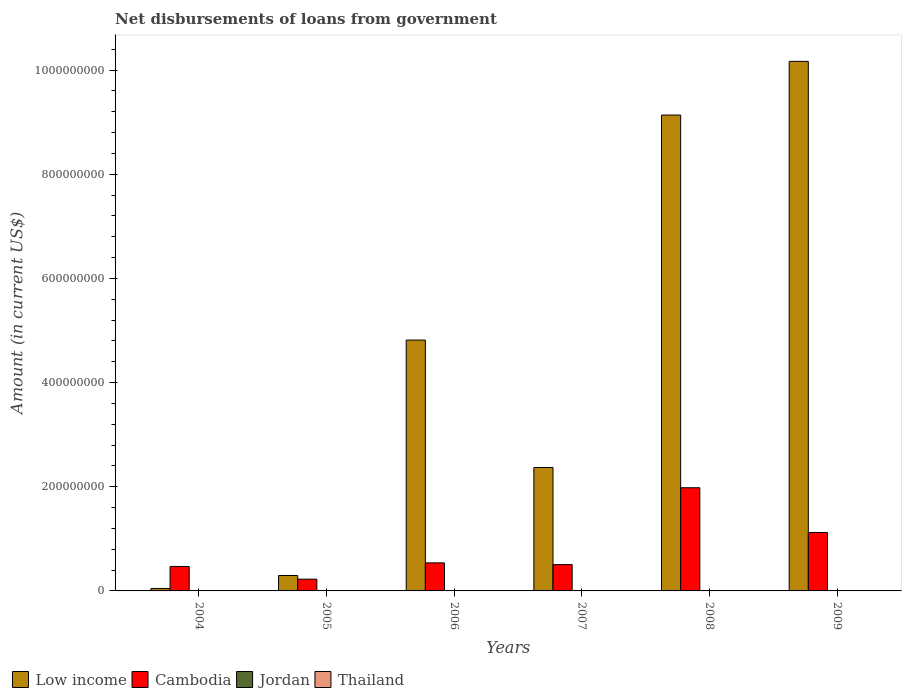What is the amount of loan disbursed from government in Low income in 2005?
Provide a short and direct response. 2.97e+07. In which year was the amount of loan disbursed from government in Cambodia maximum?
Make the answer very short. 2008. What is the total amount of loan disbursed from government in Cambodia in the graph?
Make the answer very short. 4.84e+08. What is the difference between the amount of loan disbursed from government in Low income in 2005 and that in 2006?
Provide a short and direct response. -4.52e+08. What is the difference between the amount of loan disbursed from government in Low income in 2009 and the amount of loan disbursed from government in Thailand in 2004?
Give a very brief answer. 1.02e+09. What is the average amount of loan disbursed from government in Jordan per year?
Keep it short and to the point. 0. In the year 2006, what is the difference between the amount of loan disbursed from government in Low income and amount of loan disbursed from government in Cambodia?
Your answer should be compact. 4.28e+08. In how many years, is the amount of loan disbursed from government in Thailand greater than 200000000 US$?
Keep it short and to the point. 0. What is the ratio of the amount of loan disbursed from government in Low income in 2004 to that in 2006?
Provide a short and direct response. 0.01. Is the amount of loan disbursed from government in Low income in 2005 less than that in 2006?
Your response must be concise. Yes. What is the difference between the highest and the second highest amount of loan disbursed from government in Cambodia?
Provide a short and direct response. 8.59e+07. What is the difference between the highest and the lowest amount of loan disbursed from government in Low income?
Provide a short and direct response. 1.01e+09. Is it the case that in every year, the sum of the amount of loan disbursed from government in Low income and amount of loan disbursed from government in Thailand is greater than the sum of amount of loan disbursed from government in Jordan and amount of loan disbursed from government in Cambodia?
Offer a very short reply. No. Is it the case that in every year, the sum of the amount of loan disbursed from government in Thailand and amount of loan disbursed from government in Low income is greater than the amount of loan disbursed from government in Cambodia?
Make the answer very short. No. Are all the bars in the graph horizontal?
Keep it short and to the point. No. How many years are there in the graph?
Your answer should be very brief. 6. Are the values on the major ticks of Y-axis written in scientific E-notation?
Your answer should be very brief. No. Does the graph contain any zero values?
Ensure brevity in your answer.  Yes. Does the graph contain grids?
Keep it short and to the point. No. How are the legend labels stacked?
Provide a succinct answer. Horizontal. What is the title of the graph?
Give a very brief answer. Net disbursements of loans from government. What is the label or title of the Y-axis?
Offer a terse response. Amount (in current US$). What is the Amount (in current US$) of Low income in 2004?
Provide a succinct answer. 4.73e+06. What is the Amount (in current US$) in Cambodia in 2004?
Your response must be concise. 4.70e+07. What is the Amount (in current US$) of Jordan in 2004?
Provide a short and direct response. 0. What is the Amount (in current US$) of Thailand in 2004?
Ensure brevity in your answer.  0. What is the Amount (in current US$) in Low income in 2005?
Provide a succinct answer. 2.97e+07. What is the Amount (in current US$) in Cambodia in 2005?
Your answer should be very brief. 2.26e+07. What is the Amount (in current US$) in Jordan in 2005?
Provide a short and direct response. 0. What is the Amount (in current US$) of Low income in 2006?
Ensure brevity in your answer.  4.82e+08. What is the Amount (in current US$) in Cambodia in 2006?
Provide a succinct answer. 5.39e+07. What is the Amount (in current US$) in Jordan in 2006?
Give a very brief answer. 0. What is the Amount (in current US$) of Thailand in 2006?
Give a very brief answer. 0. What is the Amount (in current US$) in Low income in 2007?
Your response must be concise. 2.37e+08. What is the Amount (in current US$) of Cambodia in 2007?
Offer a terse response. 5.05e+07. What is the Amount (in current US$) of Jordan in 2007?
Offer a terse response. 0. What is the Amount (in current US$) of Low income in 2008?
Make the answer very short. 9.14e+08. What is the Amount (in current US$) of Cambodia in 2008?
Keep it short and to the point. 1.98e+08. What is the Amount (in current US$) in Low income in 2009?
Give a very brief answer. 1.02e+09. What is the Amount (in current US$) in Cambodia in 2009?
Give a very brief answer. 1.12e+08. What is the Amount (in current US$) in Jordan in 2009?
Offer a very short reply. 0. Across all years, what is the maximum Amount (in current US$) in Low income?
Ensure brevity in your answer.  1.02e+09. Across all years, what is the maximum Amount (in current US$) in Cambodia?
Your answer should be compact. 1.98e+08. Across all years, what is the minimum Amount (in current US$) of Low income?
Ensure brevity in your answer.  4.73e+06. Across all years, what is the minimum Amount (in current US$) of Cambodia?
Keep it short and to the point. 2.26e+07. What is the total Amount (in current US$) in Low income in the graph?
Provide a succinct answer. 2.68e+09. What is the total Amount (in current US$) of Cambodia in the graph?
Your answer should be compact. 4.84e+08. What is the total Amount (in current US$) in Jordan in the graph?
Offer a terse response. 0. What is the difference between the Amount (in current US$) in Low income in 2004 and that in 2005?
Ensure brevity in your answer.  -2.49e+07. What is the difference between the Amount (in current US$) in Cambodia in 2004 and that in 2005?
Offer a very short reply. 2.44e+07. What is the difference between the Amount (in current US$) of Low income in 2004 and that in 2006?
Provide a succinct answer. -4.77e+08. What is the difference between the Amount (in current US$) of Cambodia in 2004 and that in 2006?
Provide a succinct answer. -6.88e+06. What is the difference between the Amount (in current US$) of Low income in 2004 and that in 2007?
Make the answer very short. -2.32e+08. What is the difference between the Amount (in current US$) of Cambodia in 2004 and that in 2007?
Your answer should be compact. -3.54e+06. What is the difference between the Amount (in current US$) in Low income in 2004 and that in 2008?
Your answer should be compact. -9.09e+08. What is the difference between the Amount (in current US$) of Cambodia in 2004 and that in 2008?
Make the answer very short. -1.51e+08. What is the difference between the Amount (in current US$) of Low income in 2004 and that in 2009?
Give a very brief answer. -1.01e+09. What is the difference between the Amount (in current US$) of Cambodia in 2004 and that in 2009?
Your answer should be very brief. -6.52e+07. What is the difference between the Amount (in current US$) in Low income in 2005 and that in 2006?
Provide a succinct answer. -4.52e+08. What is the difference between the Amount (in current US$) in Cambodia in 2005 and that in 2006?
Ensure brevity in your answer.  -3.13e+07. What is the difference between the Amount (in current US$) in Low income in 2005 and that in 2007?
Provide a succinct answer. -2.07e+08. What is the difference between the Amount (in current US$) in Cambodia in 2005 and that in 2007?
Offer a very short reply. -2.79e+07. What is the difference between the Amount (in current US$) of Low income in 2005 and that in 2008?
Provide a short and direct response. -8.84e+08. What is the difference between the Amount (in current US$) in Cambodia in 2005 and that in 2008?
Give a very brief answer. -1.76e+08. What is the difference between the Amount (in current US$) of Low income in 2005 and that in 2009?
Keep it short and to the point. -9.87e+08. What is the difference between the Amount (in current US$) of Cambodia in 2005 and that in 2009?
Give a very brief answer. -8.96e+07. What is the difference between the Amount (in current US$) of Low income in 2006 and that in 2007?
Make the answer very short. 2.45e+08. What is the difference between the Amount (in current US$) of Cambodia in 2006 and that in 2007?
Your answer should be very brief. 3.34e+06. What is the difference between the Amount (in current US$) of Low income in 2006 and that in 2008?
Offer a terse response. -4.32e+08. What is the difference between the Amount (in current US$) in Cambodia in 2006 and that in 2008?
Your answer should be very brief. -1.44e+08. What is the difference between the Amount (in current US$) of Low income in 2006 and that in 2009?
Provide a succinct answer. -5.35e+08. What is the difference between the Amount (in current US$) of Cambodia in 2006 and that in 2009?
Make the answer very short. -5.84e+07. What is the difference between the Amount (in current US$) in Low income in 2007 and that in 2008?
Keep it short and to the point. -6.77e+08. What is the difference between the Amount (in current US$) in Cambodia in 2007 and that in 2008?
Offer a very short reply. -1.48e+08. What is the difference between the Amount (in current US$) of Low income in 2007 and that in 2009?
Offer a terse response. -7.80e+08. What is the difference between the Amount (in current US$) of Cambodia in 2007 and that in 2009?
Ensure brevity in your answer.  -6.17e+07. What is the difference between the Amount (in current US$) of Low income in 2008 and that in 2009?
Your response must be concise. -1.03e+08. What is the difference between the Amount (in current US$) of Cambodia in 2008 and that in 2009?
Your answer should be compact. 8.59e+07. What is the difference between the Amount (in current US$) of Low income in 2004 and the Amount (in current US$) of Cambodia in 2005?
Make the answer very short. -1.78e+07. What is the difference between the Amount (in current US$) in Low income in 2004 and the Amount (in current US$) in Cambodia in 2006?
Offer a very short reply. -4.91e+07. What is the difference between the Amount (in current US$) in Low income in 2004 and the Amount (in current US$) in Cambodia in 2007?
Your response must be concise. -4.58e+07. What is the difference between the Amount (in current US$) in Low income in 2004 and the Amount (in current US$) in Cambodia in 2008?
Offer a terse response. -1.93e+08. What is the difference between the Amount (in current US$) in Low income in 2004 and the Amount (in current US$) in Cambodia in 2009?
Your answer should be compact. -1.07e+08. What is the difference between the Amount (in current US$) in Low income in 2005 and the Amount (in current US$) in Cambodia in 2006?
Make the answer very short. -2.42e+07. What is the difference between the Amount (in current US$) of Low income in 2005 and the Amount (in current US$) of Cambodia in 2007?
Ensure brevity in your answer.  -2.09e+07. What is the difference between the Amount (in current US$) of Low income in 2005 and the Amount (in current US$) of Cambodia in 2008?
Your answer should be very brief. -1.68e+08. What is the difference between the Amount (in current US$) of Low income in 2005 and the Amount (in current US$) of Cambodia in 2009?
Your answer should be very brief. -8.26e+07. What is the difference between the Amount (in current US$) of Low income in 2006 and the Amount (in current US$) of Cambodia in 2007?
Make the answer very short. 4.31e+08. What is the difference between the Amount (in current US$) of Low income in 2006 and the Amount (in current US$) of Cambodia in 2008?
Your answer should be very brief. 2.84e+08. What is the difference between the Amount (in current US$) in Low income in 2006 and the Amount (in current US$) in Cambodia in 2009?
Provide a succinct answer. 3.69e+08. What is the difference between the Amount (in current US$) of Low income in 2007 and the Amount (in current US$) of Cambodia in 2008?
Offer a terse response. 3.89e+07. What is the difference between the Amount (in current US$) in Low income in 2007 and the Amount (in current US$) in Cambodia in 2009?
Ensure brevity in your answer.  1.25e+08. What is the difference between the Amount (in current US$) of Low income in 2008 and the Amount (in current US$) of Cambodia in 2009?
Your answer should be very brief. 8.01e+08. What is the average Amount (in current US$) of Low income per year?
Provide a succinct answer. 4.47e+08. What is the average Amount (in current US$) of Cambodia per year?
Your answer should be compact. 8.07e+07. What is the average Amount (in current US$) of Thailand per year?
Your answer should be very brief. 0. In the year 2004, what is the difference between the Amount (in current US$) of Low income and Amount (in current US$) of Cambodia?
Your answer should be very brief. -4.22e+07. In the year 2005, what is the difference between the Amount (in current US$) in Low income and Amount (in current US$) in Cambodia?
Give a very brief answer. 7.09e+06. In the year 2006, what is the difference between the Amount (in current US$) in Low income and Amount (in current US$) in Cambodia?
Give a very brief answer. 4.28e+08. In the year 2007, what is the difference between the Amount (in current US$) in Low income and Amount (in current US$) in Cambodia?
Keep it short and to the point. 1.86e+08. In the year 2008, what is the difference between the Amount (in current US$) in Low income and Amount (in current US$) in Cambodia?
Offer a terse response. 7.16e+08. In the year 2009, what is the difference between the Amount (in current US$) in Low income and Amount (in current US$) in Cambodia?
Ensure brevity in your answer.  9.05e+08. What is the ratio of the Amount (in current US$) of Low income in 2004 to that in 2005?
Ensure brevity in your answer.  0.16. What is the ratio of the Amount (in current US$) in Cambodia in 2004 to that in 2005?
Offer a very short reply. 2.08. What is the ratio of the Amount (in current US$) in Low income in 2004 to that in 2006?
Provide a succinct answer. 0.01. What is the ratio of the Amount (in current US$) in Cambodia in 2004 to that in 2006?
Ensure brevity in your answer.  0.87. What is the ratio of the Amount (in current US$) of Cambodia in 2004 to that in 2007?
Provide a short and direct response. 0.93. What is the ratio of the Amount (in current US$) of Low income in 2004 to that in 2008?
Your response must be concise. 0.01. What is the ratio of the Amount (in current US$) in Cambodia in 2004 to that in 2008?
Give a very brief answer. 0.24. What is the ratio of the Amount (in current US$) of Low income in 2004 to that in 2009?
Provide a short and direct response. 0. What is the ratio of the Amount (in current US$) in Cambodia in 2004 to that in 2009?
Provide a short and direct response. 0.42. What is the ratio of the Amount (in current US$) in Low income in 2005 to that in 2006?
Your answer should be compact. 0.06. What is the ratio of the Amount (in current US$) in Cambodia in 2005 to that in 2006?
Make the answer very short. 0.42. What is the ratio of the Amount (in current US$) of Low income in 2005 to that in 2007?
Offer a terse response. 0.13. What is the ratio of the Amount (in current US$) of Cambodia in 2005 to that in 2007?
Make the answer very short. 0.45. What is the ratio of the Amount (in current US$) of Low income in 2005 to that in 2008?
Make the answer very short. 0.03. What is the ratio of the Amount (in current US$) of Cambodia in 2005 to that in 2008?
Provide a succinct answer. 0.11. What is the ratio of the Amount (in current US$) of Low income in 2005 to that in 2009?
Provide a succinct answer. 0.03. What is the ratio of the Amount (in current US$) in Cambodia in 2005 to that in 2009?
Make the answer very short. 0.2. What is the ratio of the Amount (in current US$) of Low income in 2006 to that in 2007?
Your response must be concise. 2.03. What is the ratio of the Amount (in current US$) in Cambodia in 2006 to that in 2007?
Provide a short and direct response. 1.07. What is the ratio of the Amount (in current US$) of Low income in 2006 to that in 2008?
Give a very brief answer. 0.53. What is the ratio of the Amount (in current US$) in Cambodia in 2006 to that in 2008?
Your answer should be compact. 0.27. What is the ratio of the Amount (in current US$) in Low income in 2006 to that in 2009?
Ensure brevity in your answer.  0.47. What is the ratio of the Amount (in current US$) in Cambodia in 2006 to that in 2009?
Provide a short and direct response. 0.48. What is the ratio of the Amount (in current US$) in Low income in 2007 to that in 2008?
Offer a very short reply. 0.26. What is the ratio of the Amount (in current US$) in Cambodia in 2007 to that in 2008?
Offer a very short reply. 0.26. What is the ratio of the Amount (in current US$) in Low income in 2007 to that in 2009?
Offer a very short reply. 0.23. What is the ratio of the Amount (in current US$) in Cambodia in 2007 to that in 2009?
Keep it short and to the point. 0.45. What is the ratio of the Amount (in current US$) in Low income in 2008 to that in 2009?
Ensure brevity in your answer.  0.9. What is the ratio of the Amount (in current US$) in Cambodia in 2008 to that in 2009?
Your response must be concise. 1.77. What is the difference between the highest and the second highest Amount (in current US$) of Low income?
Your answer should be very brief. 1.03e+08. What is the difference between the highest and the second highest Amount (in current US$) of Cambodia?
Ensure brevity in your answer.  8.59e+07. What is the difference between the highest and the lowest Amount (in current US$) in Low income?
Your answer should be very brief. 1.01e+09. What is the difference between the highest and the lowest Amount (in current US$) of Cambodia?
Give a very brief answer. 1.76e+08. 